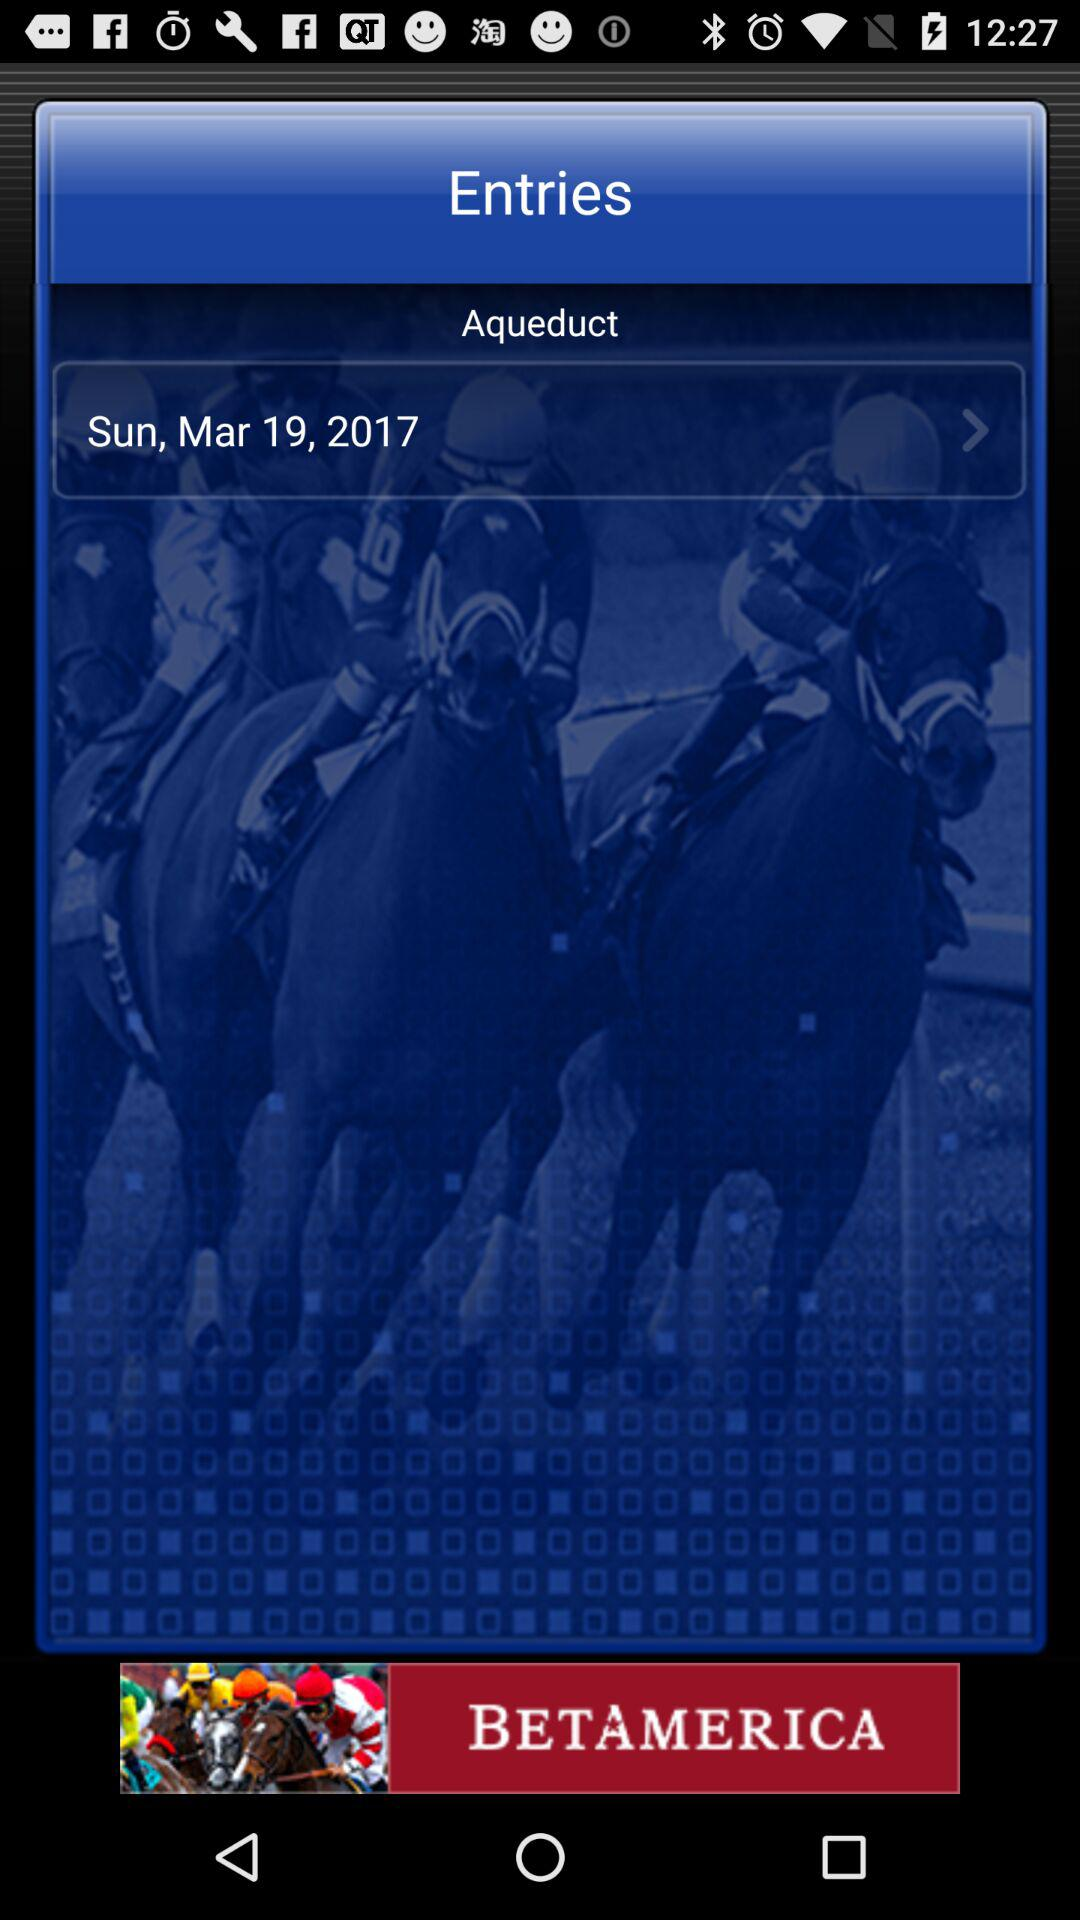What day falls on March 19, 2017? On March 19, 2017, the day is Sunday. 